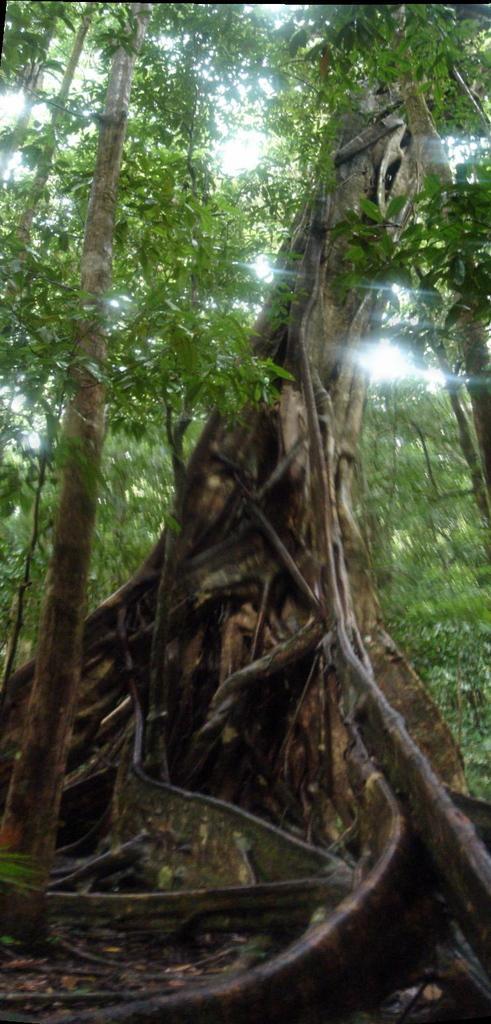Could you give a brief overview of what you see in this image? In this image there are some trees, and at the bottom there are dry leaves and also there are some wooden sticks. 